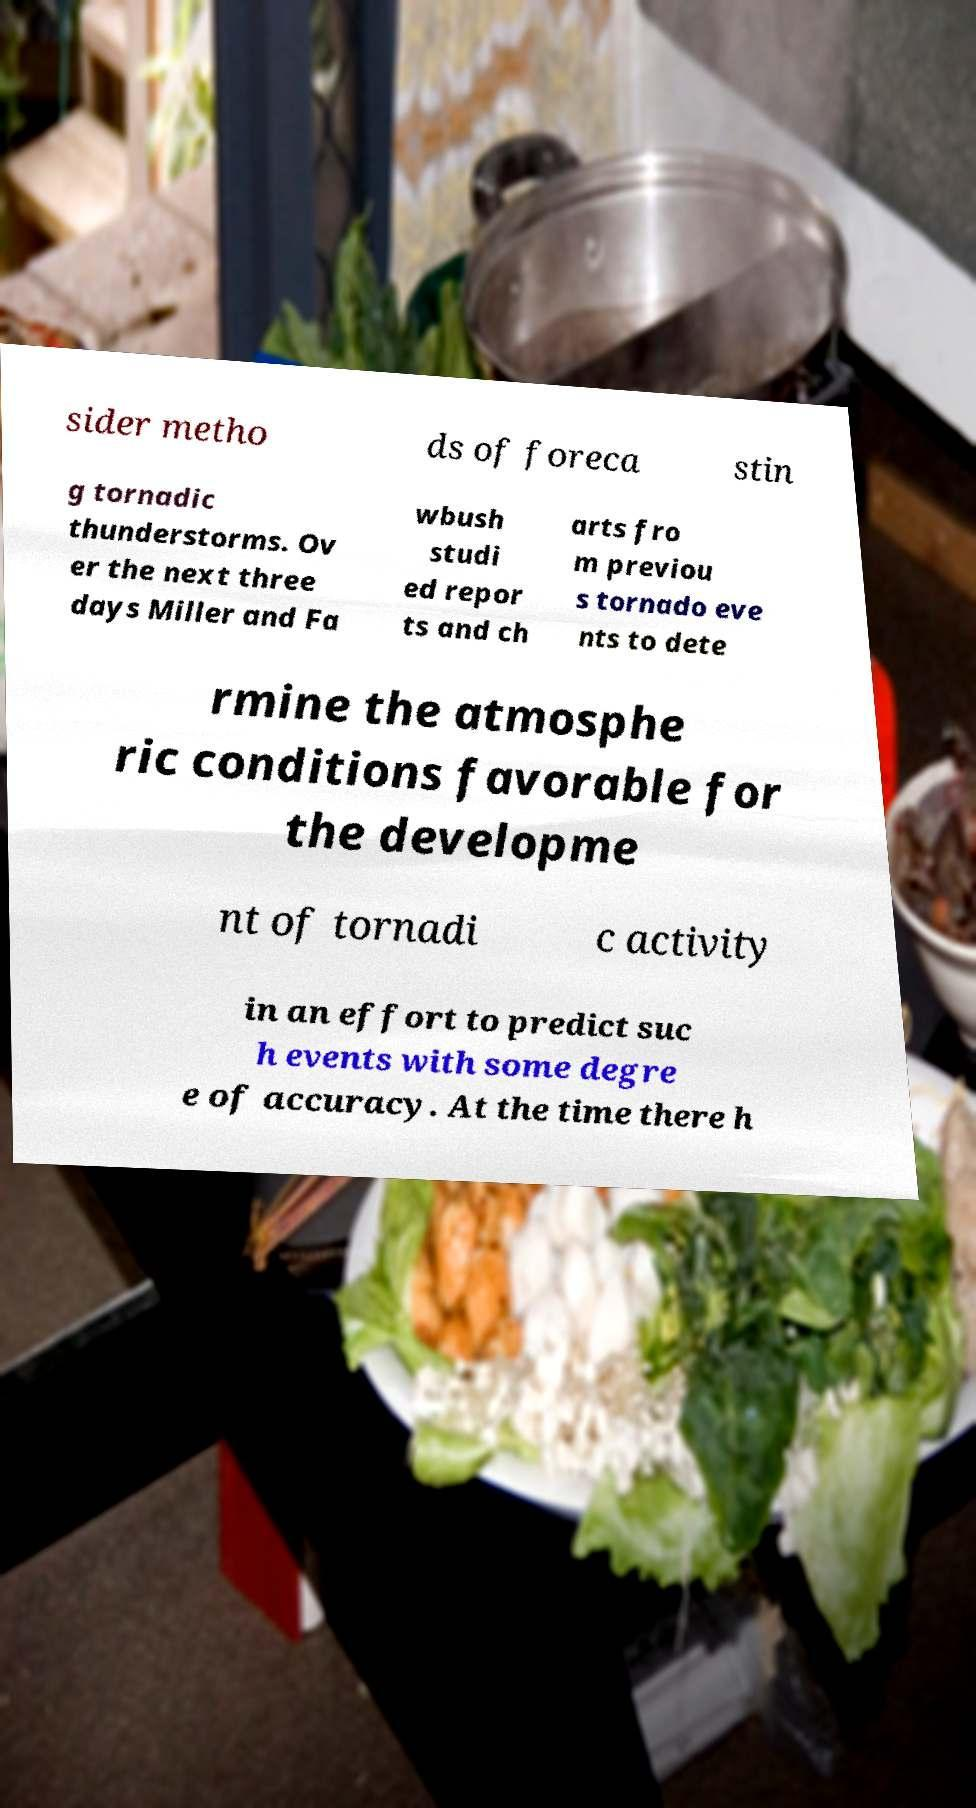Please read and relay the text visible in this image. What does it say? sider metho ds of foreca stin g tornadic thunderstorms. Ov er the next three days Miller and Fa wbush studi ed repor ts and ch arts fro m previou s tornado eve nts to dete rmine the atmosphe ric conditions favorable for the developme nt of tornadi c activity in an effort to predict suc h events with some degre e of accuracy. At the time there h 